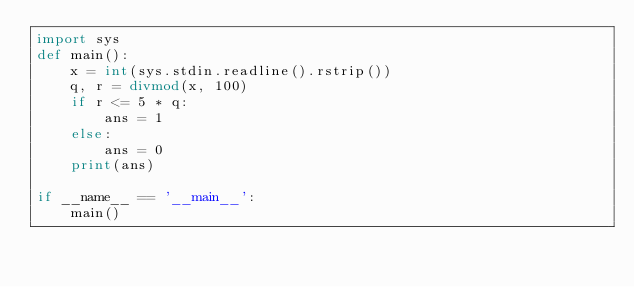Convert code to text. <code><loc_0><loc_0><loc_500><loc_500><_Python_>import sys
def main():
    x = int(sys.stdin.readline().rstrip())
    q, r = divmod(x, 100)
    if r <= 5 * q:
        ans = 1
    else:
        ans = 0
    print(ans)

if __name__ == '__main__':
    main()</code> 